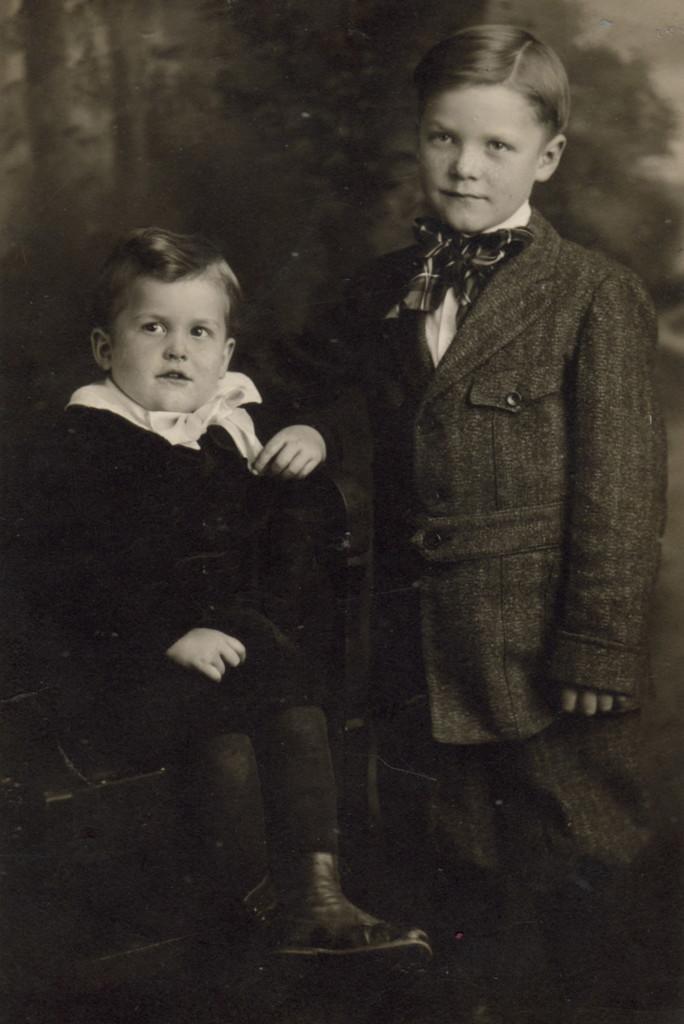Please provide a concise description of this image. In this picture there are two kids. In the background of the image it is blurry. 